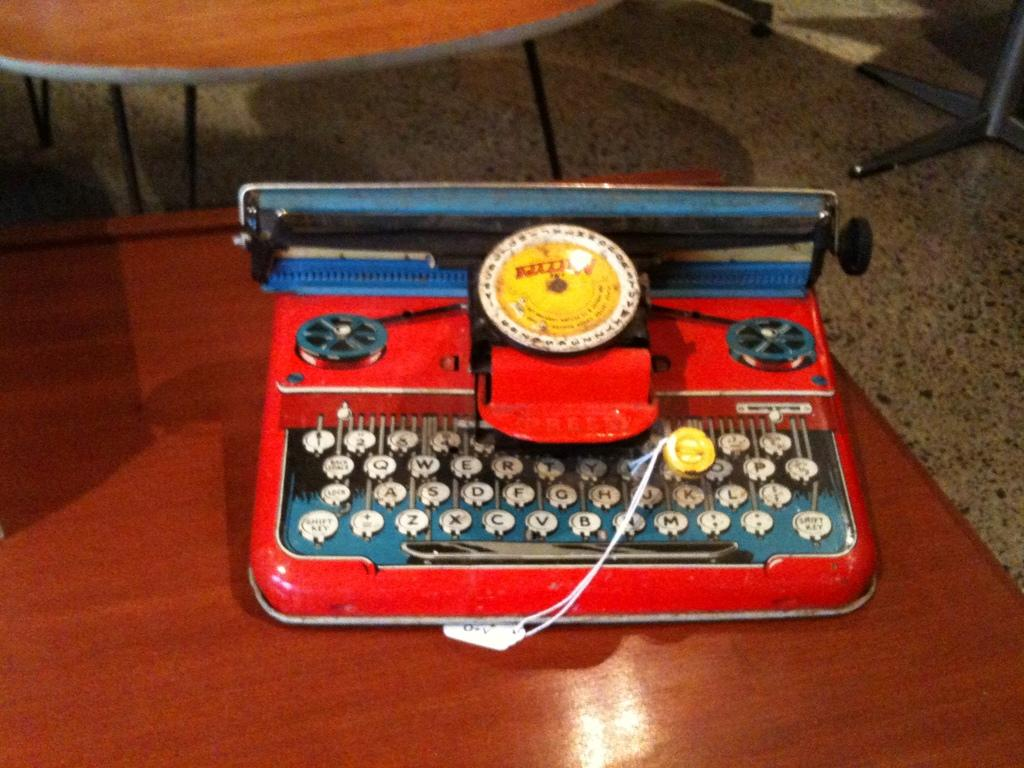Provide a one-sentence caption for the provided image. A red device has a keyboard with keys reading z, x and c. 